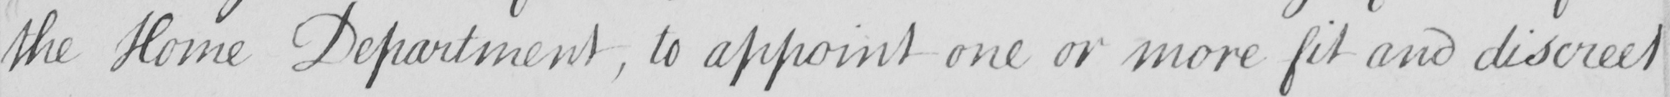What does this handwritten line say? the Home Department , to appoint one or more fit and discreet 